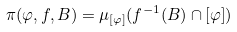<formula> <loc_0><loc_0><loc_500><loc_500>\pi ( \varphi , f , B ) = \mu _ { \left [ \varphi \right ] } ( f ^ { - 1 } ( B ) \cap \left [ \varphi \right ] )</formula> 